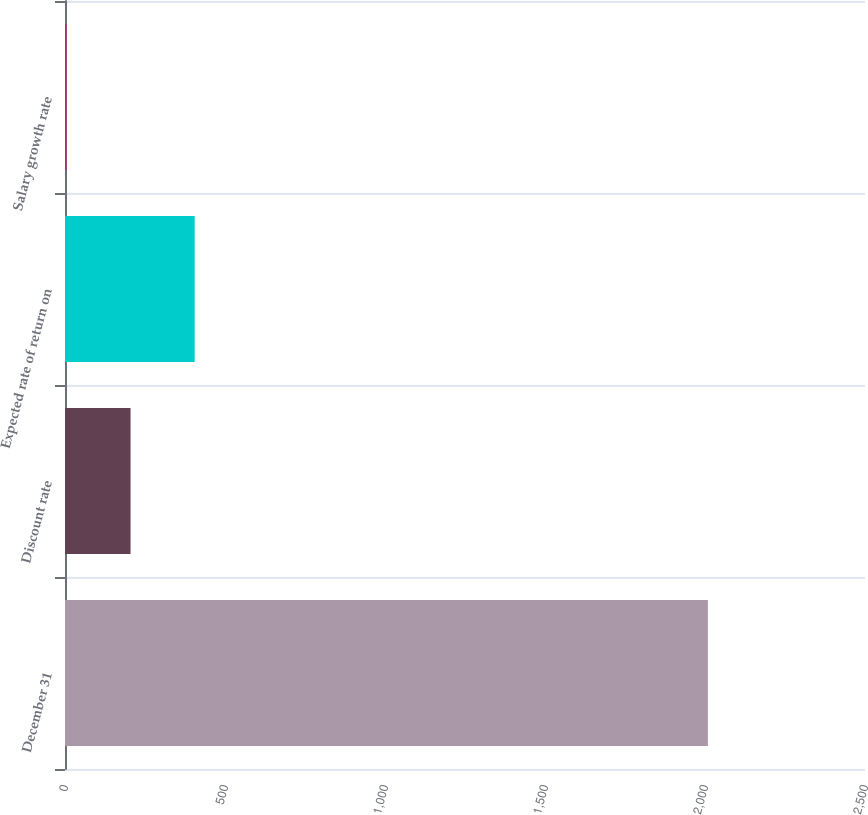<chart> <loc_0><loc_0><loc_500><loc_500><bar_chart><fcel>December 31<fcel>Discount rate<fcel>Expected rate of return on<fcel>Salary growth rate<nl><fcel>2009<fcel>204.77<fcel>405.24<fcel>4.3<nl></chart> 